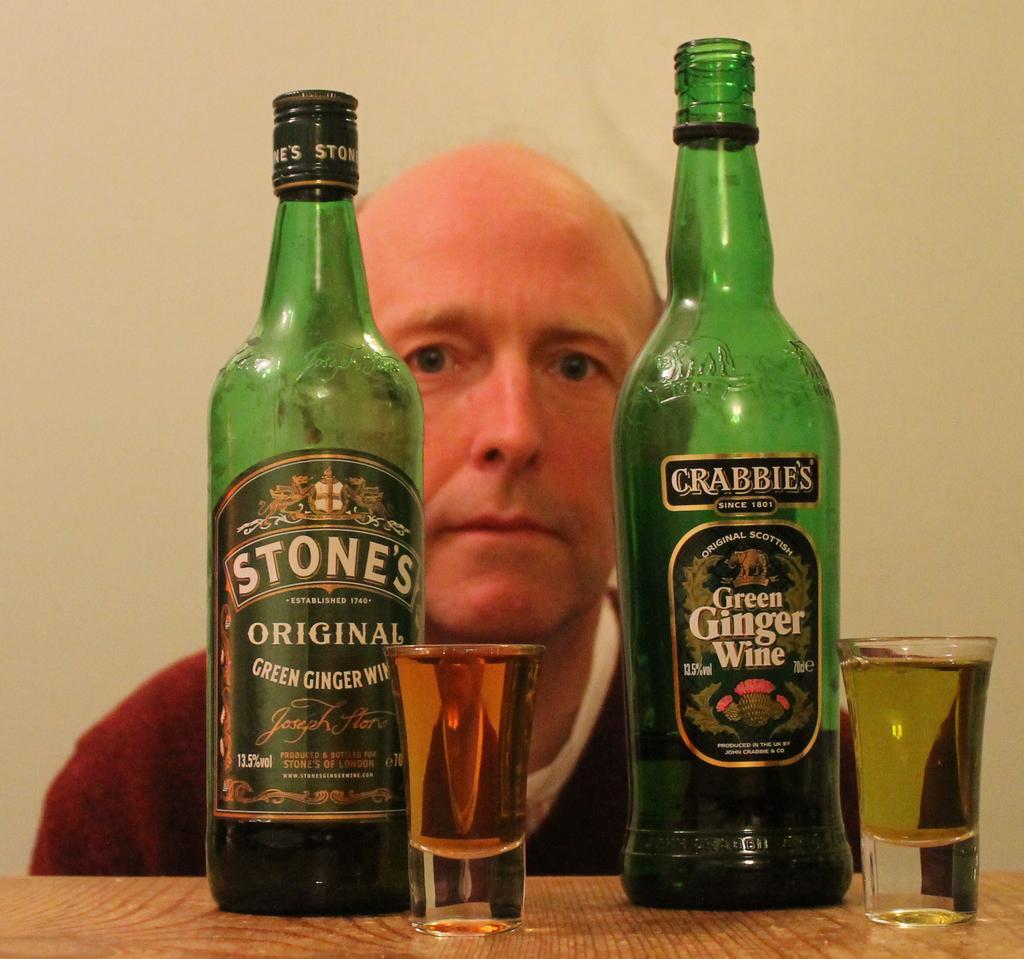Can you describe this image briefly? There are two wine bottles which are green in color and two glasses placed on the table. Here is a man behind the table. 